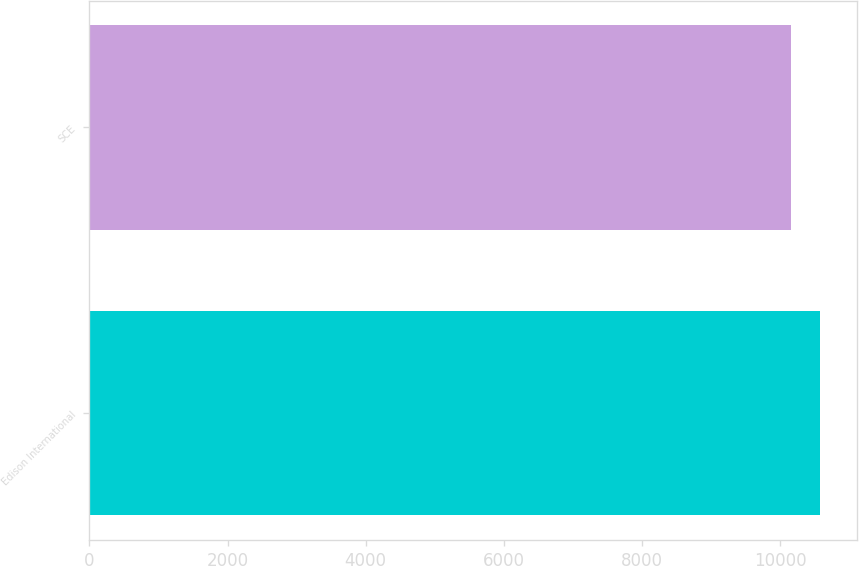<chart> <loc_0><loc_0><loc_500><loc_500><bar_chart><fcel>Edison International<fcel>SCE<nl><fcel>10578<fcel>10153<nl></chart> 